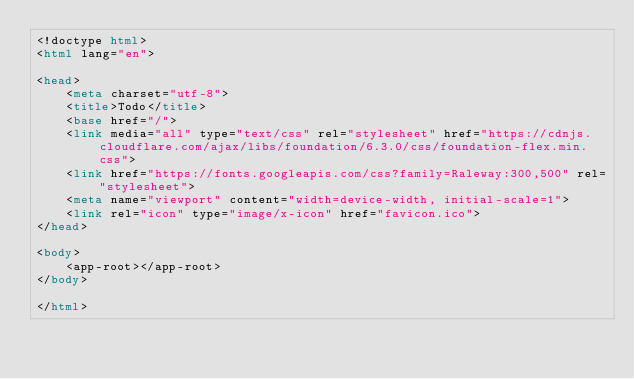Convert code to text. <code><loc_0><loc_0><loc_500><loc_500><_HTML_><!doctype html>
<html lang="en">

<head>
    <meta charset="utf-8">
    <title>Todo</title>
    <base href="/">
    <link media="all" type="text/css" rel="stylesheet" href="https://cdnjs.cloudflare.com/ajax/libs/foundation/6.3.0/css/foundation-flex.min.css">
    <link href="https://fonts.googleapis.com/css?family=Raleway:300,500" rel="stylesheet">
    <meta name="viewport" content="width=device-width, initial-scale=1">
    <link rel="icon" type="image/x-icon" href="favicon.ico">
</head>

<body>
    <app-root></app-root>
</body>

</html></code> 